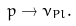<formula> <loc_0><loc_0><loc_500><loc_500>p \rightarrow \nu _ { P l } .</formula> 